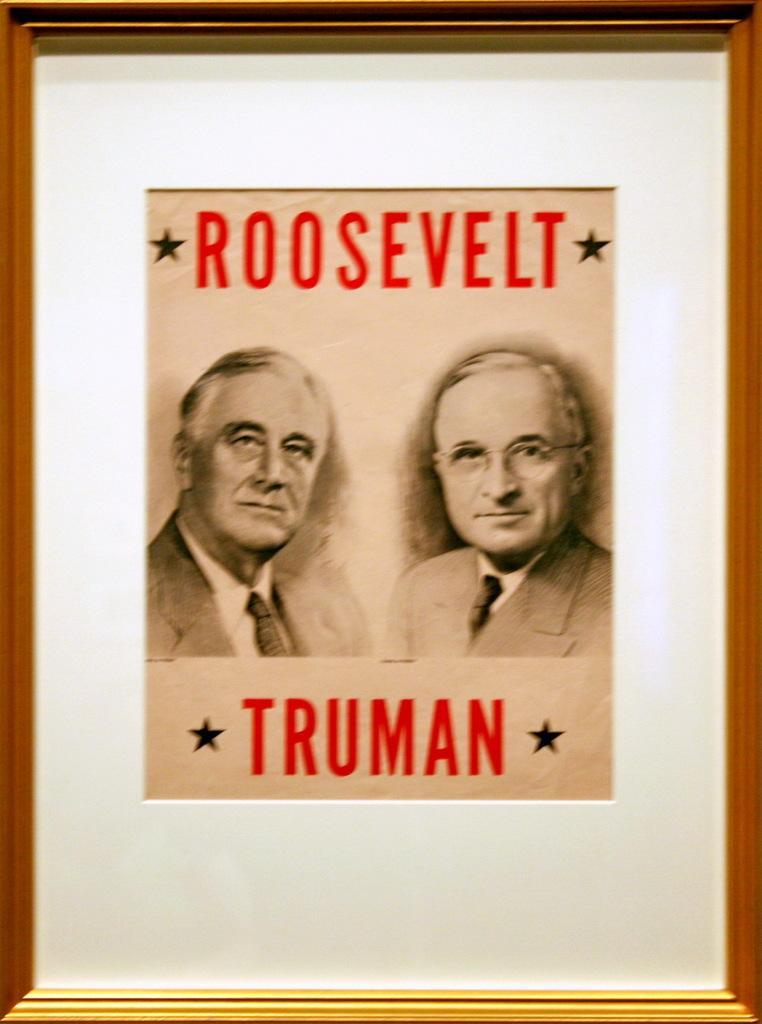Could you give a brief overview of what you see in this image? In this picture we can see a frame. On the frame there are two persons. 